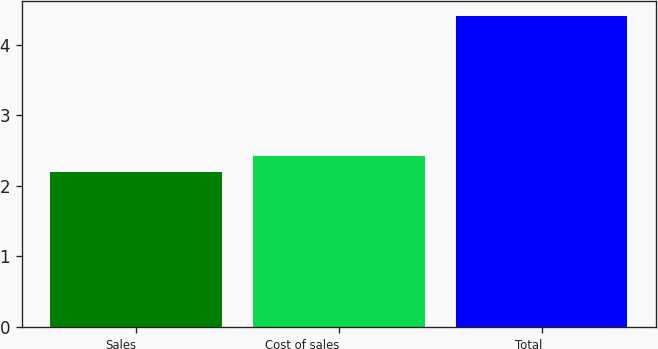<chart> <loc_0><loc_0><loc_500><loc_500><bar_chart><fcel>Sales<fcel>Cost of sales<fcel>Total<nl><fcel>2.2<fcel>2.42<fcel>4.4<nl></chart> 